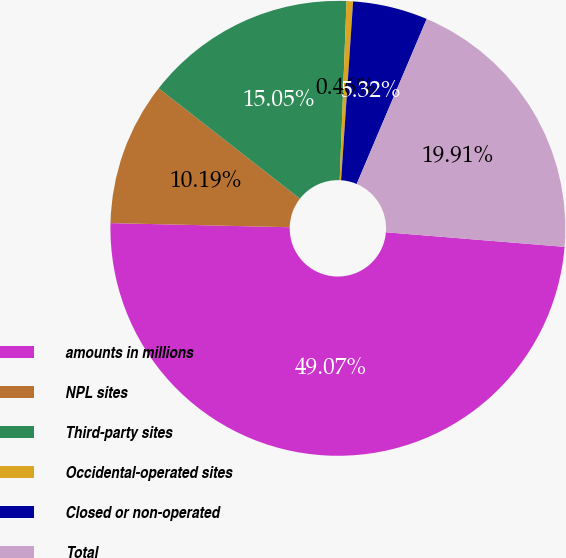<chart> <loc_0><loc_0><loc_500><loc_500><pie_chart><fcel>amounts in millions<fcel>NPL sites<fcel>Third-party sites<fcel>Occidental-operated sites<fcel>Closed or non-operated<fcel>Total<nl><fcel>49.07%<fcel>10.19%<fcel>15.05%<fcel>0.46%<fcel>5.32%<fcel>19.91%<nl></chart> 